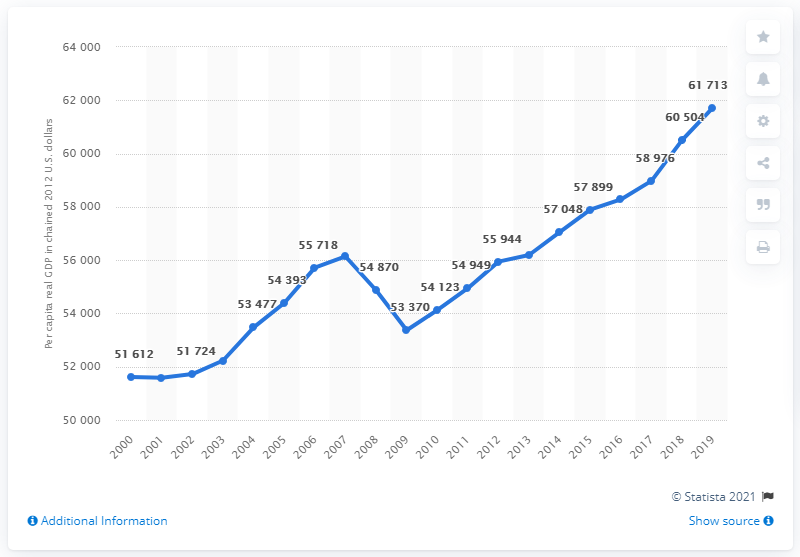Point out several critical features in this image. From 2007 to 2009, the median per capita real GDP was greater than the average. The two data points that dropped from their preceding data point are [54870, 53370]. In 2012, the per capita real GDP of Illinois stood at 61,713, when adjusted for inflation using the chain-weighted method. 